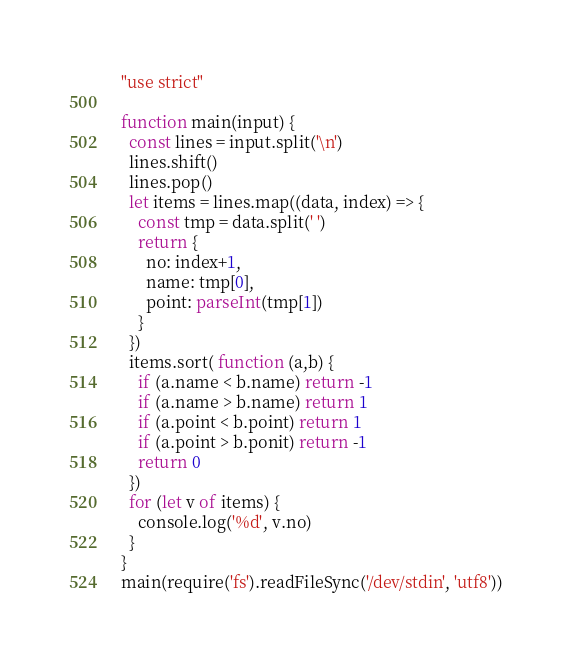Convert code to text. <code><loc_0><loc_0><loc_500><loc_500><_JavaScript_>"use strict"

function main(input) {
  const lines = input.split('\n')
  lines.shift()
  lines.pop()
  let items = lines.map((data, index) => {
    const tmp = data.split(' ')
    return {
      no: index+1,
      name: tmp[0],
      point: parseInt(tmp[1])
    }
  })
  items.sort( function (a,b) {
    if (a.name < b.name) return -1
    if (a.name > b.name) return 1
    if (a.point < b.point) return 1
    if (a.point > b.ponit) return -1
    return 0
  })
  for (let v of items) {
    console.log('%d', v.no)
  }
} 
main(require('fs').readFileSync('/dev/stdin', 'utf8'))</code> 